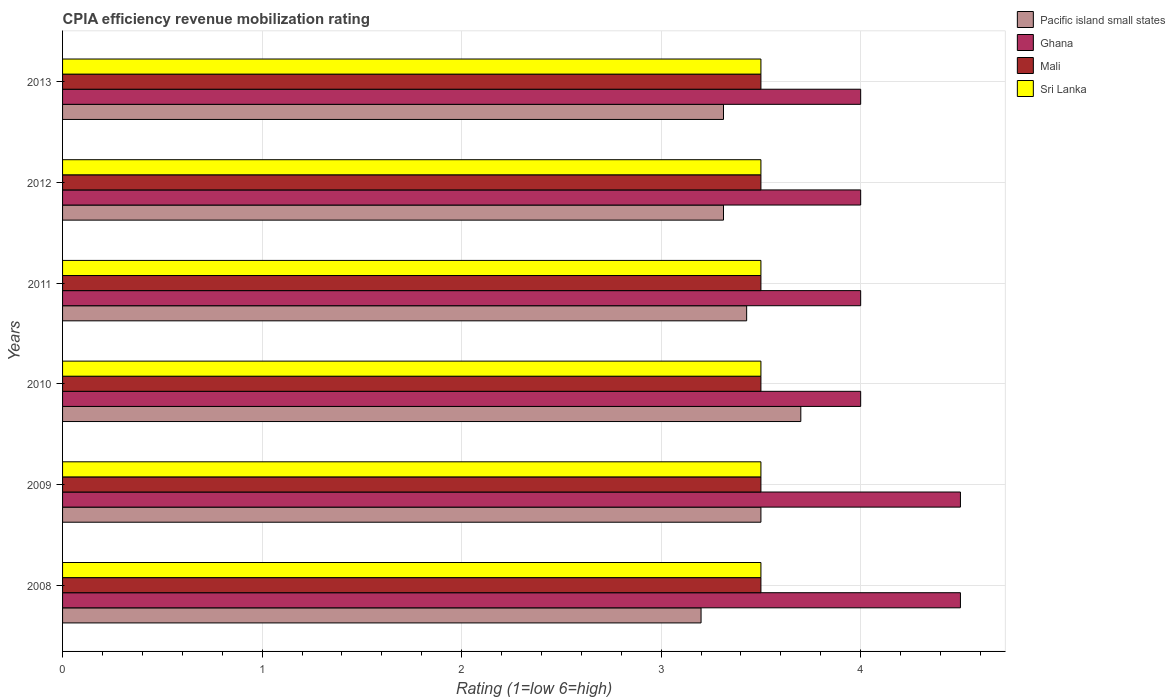How many different coloured bars are there?
Your answer should be compact. 4. How many groups of bars are there?
Your answer should be very brief. 6. Are the number of bars per tick equal to the number of legend labels?
Keep it short and to the point. Yes. Are the number of bars on each tick of the Y-axis equal?
Ensure brevity in your answer.  Yes. What is the label of the 5th group of bars from the top?
Offer a very short reply. 2009. Across all years, what is the maximum CPIA rating in Sri Lanka?
Keep it short and to the point. 3.5. In which year was the CPIA rating in Ghana maximum?
Ensure brevity in your answer.  2008. What is the total CPIA rating in Mali in the graph?
Ensure brevity in your answer.  21. What is the difference between the CPIA rating in Pacific island small states in 2012 and that in 2013?
Offer a terse response. 0. What is the difference between the CPIA rating in Mali in 2009 and the CPIA rating in Pacific island small states in 2011?
Provide a succinct answer. 0.07. What is the average CPIA rating in Ghana per year?
Ensure brevity in your answer.  4.17. In the year 2012, what is the difference between the CPIA rating in Mali and CPIA rating in Pacific island small states?
Your answer should be very brief. 0.19. Is the CPIA rating in Sri Lanka in 2009 less than that in 2013?
Ensure brevity in your answer.  No. What is the difference between the highest and the second highest CPIA rating in Sri Lanka?
Keep it short and to the point. 0. What is the difference between the highest and the lowest CPIA rating in Ghana?
Provide a short and direct response. 0.5. Is the sum of the CPIA rating in Mali in 2010 and 2012 greater than the maximum CPIA rating in Sri Lanka across all years?
Ensure brevity in your answer.  Yes. What does the 2nd bar from the top in 2009 represents?
Make the answer very short. Mali. What does the 3rd bar from the bottom in 2012 represents?
Make the answer very short. Mali. How many bars are there?
Offer a terse response. 24. Are all the bars in the graph horizontal?
Make the answer very short. Yes. Does the graph contain grids?
Your response must be concise. Yes. How many legend labels are there?
Make the answer very short. 4. How are the legend labels stacked?
Your answer should be very brief. Vertical. What is the title of the graph?
Provide a succinct answer. CPIA efficiency revenue mobilization rating. What is the label or title of the X-axis?
Offer a terse response. Rating (1=low 6=high). What is the Rating (1=low 6=high) of Mali in 2008?
Ensure brevity in your answer.  3.5. What is the Rating (1=low 6=high) in Sri Lanka in 2008?
Offer a very short reply. 3.5. What is the Rating (1=low 6=high) in Pacific island small states in 2009?
Provide a short and direct response. 3.5. What is the Rating (1=low 6=high) in Mali in 2009?
Offer a terse response. 3.5. What is the Rating (1=low 6=high) of Sri Lanka in 2010?
Offer a very short reply. 3.5. What is the Rating (1=low 6=high) in Pacific island small states in 2011?
Make the answer very short. 3.43. What is the Rating (1=low 6=high) of Ghana in 2011?
Keep it short and to the point. 4. What is the Rating (1=low 6=high) of Sri Lanka in 2011?
Keep it short and to the point. 3.5. What is the Rating (1=low 6=high) of Pacific island small states in 2012?
Ensure brevity in your answer.  3.31. What is the Rating (1=low 6=high) in Ghana in 2012?
Ensure brevity in your answer.  4. What is the Rating (1=low 6=high) in Mali in 2012?
Keep it short and to the point. 3.5. What is the Rating (1=low 6=high) in Pacific island small states in 2013?
Your response must be concise. 3.31. What is the Rating (1=low 6=high) of Ghana in 2013?
Your response must be concise. 4. What is the Rating (1=low 6=high) of Sri Lanka in 2013?
Give a very brief answer. 3.5. Across all years, what is the maximum Rating (1=low 6=high) of Sri Lanka?
Your answer should be very brief. 3.5. Across all years, what is the minimum Rating (1=low 6=high) in Pacific island small states?
Provide a succinct answer. 3.2. Across all years, what is the minimum Rating (1=low 6=high) in Ghana?
Your answer should be very brief. 4. Across all years, what is the minimum Rating (1=low 6=high) in Mali?
Your answer should be very brief. 3.5. Across all years, what is the minimum Rating (1=low 6=high) in Sri Lanka?
Offer a very short reply. 3.5. What is the total Rating (1=low 6=high) in Pacific island small states in the graph?
Make the answer very short. 20.45. What is the total Rating (1=low 6=high) of Mali in the graph?
Offer a terse response. 21. What is the total Rating (1=low 6=high) of Sri Lanka in the graph?
Your answer should be compact. 21. What is the difference between the Rating (1=low 6=high) of Pacific island small states in 2008 and that in 2009?
Your answer should be compact. -0.3. What is the difference between the Rating (1=low 6=high) in Ghana in 2008 and that in 2009?
Keep it short and to the point. 0. What is the difference between the Rating (1=low 6=high) of Mali in 2008 and that in 2009?
Make the answer very short. 0. What is the difference between the Rating (1=low 6=high) in Sri Lanka in 2008 and that in 2009?
Provide a succinct answer. 0. What is the difference between the Rating (1=low 6=high) of Mali in 2008 and that in 2010?
Provide a succinct answer. 0. What is the difference between the Rating (1=low 6=high) in Sri Lanka in 2008 and that in 2010?
Give a very brief answer. 0. What is the difference between the Rating (1=low 6=high) of Pacific island small states in 2008 and that in 2011?
Offer a very short reply. -0.23. What is the difference between the Rating (1=low 6=high) in Ghana in 2008 and that in 2011?
Give a very brief answer. 0.5. What is the difference between the Rating (1=low 6=high) of Mali in 2008 and that in 2011?
Your answer should be very brief. 0. What is the difference between the Rating (1=low 6=high) in Pacific island small states in 2008 and that in 2012?
Offer a terse response. -0.11. What is the difference between the Rating (1=low 6=high) in Sri Lanka in 2008 and that in 2012?
Your response must be concise. 0. What is the difference between the Rating (1=low 6=high) of Pacific island small states in 2008 and that in 2013?
Your answer should be very brief. -0.11. What is the difference between the Rating (1=low 6=high) in Ghana in 2008 and that in 2013?
Provide a succinct answer. 0.5. What is the difference between the Rating (1=low 6=high) in Mali in 2008 and that in 2013?
Provide a succinct answer. 0. What is the difference between the Rating (1=low 6=high) in Sri Lanka in 2008 and that in 2013?
Your answer should be very brief. 0. What is the difference between the Rating (1=low 6=high) of Pacific island small states in 2009 and that in 2010?
Provide a short and direct response. -0.2. What is the difference between the Rating (1=low 6=high) in Pacific island small states in 2009 and that in 2011?
Keep it short and to the point. 0.07. What is the difference between the Rating (1=low 6=high) in Mali in 2009 and that in 2011?
Your answer should be compact. 0. What is the difference between the Rating (1=low 6=high) in Sri Lanka in 2009 and that in 2011?
Provide a succinct answer. 0. What is the difference between the Rating (1=low 6=high) in Pacific island small states in 2009 and that in 2012?
Offer a terse response. 0.19. What is the difference between the Rating (1=low 6=high) of Sri Lanka in 2009 and that in 2012?
Your answer should be very brief. 0. What is the difference between the Rating (1=low 6=high) in Pacific island small states in 2009 and that in 2013?
Ensure brevity in your answer.  0.19. What is the difference between the Rating (1=low 6=high) of Ghana in 2009 and that in 2013?
Ensure brevity in your answer.  0.5. What is the difference between the Rating (1=low 6=high) of Mali in 2009 and that in 2013?
Your answer should be compact. 0. What is the difference between the Rating (1=low 6=high) in Sri Lanka in 2009 and that in 2013?
Your answer should be very brief. 0. What is the difference between the Rating (1=low 6=high) in Pacific island small states in 2010 and that in 2011?
Provide a short and direct response. 0.27. What is the difference between the Rating (1=low 6=high) in Ghana in 2010 and that in 2011?
Your response must be concise. 0. What is the difference between the Rating (1=low 6=high) in Sri Lanka in 2010 and that in 2011?
Your answer should be compact. 0. What is the difference between the Rating (1=low 6=high) in Pacific island small states in 2010 and that in 2012?
Your answer should be compact. 0.39. What is the difference between the Rating (1=low 6=high) in Mali in 2010 and that in 2012?
Offer a very short reply. 0. What is the difference between the Rating (1=low 6=high) in Pacific island small states in 2010 and that in 2013?
Make the answer very short. 0.39. What is the difference between the Rating (1=low 6=high) in Pacific island small states in 2011 and that in 2012?
Keep it short and to the point. 0.12. What is the difference between the Rating (1=low 6=high) of Sri Lanka in 2011 and that in 2012?
Provide a succinct answer. 0. What is the difference between the Rating (1=low 6=high) in Pacific island small states in 2011 and that in 2013?
Provide a succinct answer. 0.12. What is the difference between the Rating (1=low 6=high) of Mali in 2011 and that in 2013?
Your answer should be very brief. 0. What is the difference between the Rating (1=low 6=high) in Sri Lanka in 2011 and that in 2013?
Make the answer very short. 0. What is the difference between the Rating (1=low 6=high) of Pacific island small states in 2012 and that in 2013?
Give a very brief answer. 0. What is the difference between the Rating (1=low 6=high) in Mali in 2012 and that in 2013?
Provide a succinct answer. 0. What is the difference between the Rating (1=low 6=high) in Sri Lanka in 2012 and that in 2013?
Make the answer very short. 0. What is the difference between the Rating (1=low 6=high) of Pacific island small states in 2008 and the Rating (1=low 6=high) of Ghana in 2009?
Your answer should be very brief. -1.3. What is the difference between the Rating (1=low 6=high) in Mali in 2008 and the Rating (1=low 6=high) in Sri Lanka in 2009?
Offer a very short reply. 0. What is the difference between the Rating (1=low 6=high) of Pacific island small states in 2008 and the Rating (1=low 6=high) of Ghana in 2010?
Ensure brevity in your answer.  -0.8. What is the difference between the Rating (1=low 6=high) of Pacific island small states in 2008 and the Rating (1=low 6=high) of Mali in 2010?
Your answer should be compact. -0.3. What is the difference between the Rating (1=low 6=high) in Pacific island small states in 2008 and the Rating (1=low 6=high) in Sri Lanka in 2010?
Make the answer very short. -0.3. What is the difference between the Rating (1=low 6=high) of Ghana in 2008 and the Rating (1=low 6=high) of Sri Lanka in 2010?
Provide a short and direct response. 1. What is the difference between the Rating (1=low 6=high) of Mali in 2008 and the Rating (1=low 6=high) of Sri Lanka in 2010?
Offer a terse response. 0. What is the difference between the Rating (1=low 6=high) of Pacific island small states in 2008 and the Rating (1=low 6=high) of Sri Lanka in 2011?
Your answer should be compact. -0.3. What is the difference between the Rating (1=low 6=high) of Ghana in 2008 and the Rating (1=low 6=high) of Mali in 2011?
Provide a succinct answer. 1. What is the difference between the Rating (1=low 6=high) of Mali in 2008 and the Rating (1=low 6=high) of Sri Lanka in 2011?
Your answer should be compact. 0. What is the difference between the Rating (1=low 6=high) of Pacific island small states in 2008 and the Rating (1=low 6=high) of Mali in 2012?
Give a very brief answer. -0.3. What is the difference between the Rating (1=low 6=high) in Ghana in 2008 and the Rating (1=low 6=high) in Sri Lanka in 2012?
Your answer should be very brief. 1. What is the difference between the Rating (1=low 6=high) in Pacific island small states in 2008 and the Rating (1=low 6=high) in Mali in 2013?
Give a very brief answer. -0.3. What is the difference between the Rating (1=low 6=high) in Pacific island small states in 2008 and the Rating (1=low 6=high) in Sri Lanka in 2013?
Give a very brief answer. -0.3. What is the difference between the Rating (1=low 6=high) in Mali in 2008 and the Rating (1=low 6=high) in Sri Lanka in 2013?
Your response must be concise. 0. What is the difference between the Rating (1=low 6=high) of Pacific island small states in 2009 and the Rating (1=low 6=high) of Ghana in 2010?
Make the answer very short. -0.5. What is the difference between the Rating (1=low 6=high) of Pacific island small states in 2009 and the Rating (1=low 6=high) of Sri Lanka in 2010?
Your response must be concise. 0. What is the difference between the Rating (1=low 6=high) in Ghana in 2009 and the Rating (1=low 6=high) in Sri Lanka in 2010?
Offer a terse response. 1. What is the difference between the Rating (1=low 6=high) in Mali in 2009 and the Rating (1=low 6=high) in Sri Lanka in 2010?
Offer a very short reply. 0. What is the difference between the Rating (1=low 6=high) in Pacific island small states in 2009 and the Rating (1=low 6=high) in Ghana in 2011?
Make the answer very short. -0.5. What is the difference between the Rating (1=low 6=high) of Pacific island small states in 2009 and the Rating (1=low 6=high) of Mali in 2011?
Provide a short and direct response. 0. What is the difference between the Rating (1=low 6=high) of Pacific island small states in 2009 and the Rating (1=low 6=high) of Sri Lanka in 2011?
Keep it short and to the point. 0. What is the difference between the Rating (1=low 6=high) in Ghana in 2009 and the Rating (1=low 6=high) in Sri Lanka in 2011?
Your answer should be compact. 1. What is the difference between the Rating (1=low 6=high) in Pacific island small states in 2009 and the Rating (1=low 6=high) in Sri Lanka in 2012?
Make the answer very short. 0. What is the difference between the Rating (1=low 6=high) in Ghana in 2009 and the Rating (1=low 6=high) in Sri Lanka in 2012?
Your response must be concise. 1. What is the difference between the Rating (1=low 6=high) in Mali in 2009 and the Rating (1=low 6=high) in Sri Lanka in 2012?
Your response must be concise. 0. What is the difference between the Rating (1=low 6=high) in Pacific island small states in 2010 and the Rating (1=low 6=high) in Ghana in 2011?
Give a very brief answer. -0.3. What is the difference between the Rating (1=low 6=high) in Pacific island small states in 2010 and the Rating (1=low 6=high) in Mali in 2011?
Offer a very short reply. 0.2. What is the difference between the Rating (1=low 6=high) in Pacific island small states in 2010 and the Rating (1=low 6=high) in Sri Lanka in 2011?
Provide a succinct answer. 0.2. What is the difference between the Rating (1=low 6=high) of Ghana in 2010 and the Rating (1=low 6=high) of Sri Lanka in 2011?
Your answer should be compact. 0.5. What is the difference between the Rating (1=low 6=high) of Pacific island small states in 2010 and the Rating (1=low 6=high) of Mali in 2012?
Make the answer very short. 0.2. What is the difference between the Rating (1=low 6=high) of Pacific island small states in 2010 and the Rating (1=low 6=high) of Sri Lanka in 2012?
Ensure brevity in your answer.  0.2. What is the difference between the Rating (1=low 6=high) of Ghana in 2010 and the Rating (1=low 6=high) of Sri Lanka in 2012?
Offer a very short reply. 0.5. What is the difference between the Rating (1=low 6=high) of Pacific island small states in 2010 and the Rating (1=low 6=high) of Ghana in 2013?
Your answer should be compact. -0.3. What is the difference between the Rating (1=low 6=high) in Pacific island small states in 2010 and the Rating (1=low 6=high) in Mali in 2013?
Your answer should be compact. 0.2. What is the difference between the Rating (1=low 6=high) of Pacific island small states in 2010 and the Rating (1=low 6=high) of Sri Lanka in 2013?
Ensure brevity in your answer.  0.2. What is the difference between the Rating (1=low 6=high) of Ghana in 2010 and the Rating (1=low 6=high) of Sri Lanka in 2013?
Your answer should be very brief. 0.5. What is the difference between the Rating (1=low 6=high) in Mali in 2010 and the Rating (1=low 6=high) in Sri Lanka in 2013?
Offer a terse response. 0. What is the difference between the Rating (1=low 6=high) in Pacific island small states in 2011 and the Rating (1=low 6=high) in Ghana in 2012?
Provide a succinct answer. -0.57. What is the difference between the Rating (1=low 6=high) in Pacific island small states in 2011 and the Rating (1=low 6=high) in Mali in 2012?
Your response must be concise. -0.07. What is the difference between the Rating (1=low 6=high) of Pacific island small states in 2011 and the Rating (1=low 6=high) of Sri Lanka in 2012?
Your answer should be compact. -0.07. What is the difference between the Rating (1=low 6=high) of Ghana in 2011 and the Rating (1=low 6=high) of Sri Lanka in 2012?
Your answer should be very brief. 0.5. What is the difference between the Rating (1=low 6=high) of Pacific island small states in 2011 and the Rating (1=low 6=high) of Ghana in 2013?
Provide a succinct answer. -0.57. What is the difference between the Rating (1=low 6=high) of Pacific island small states in 2011 and the Rating (1=low 6=high) of Mali in 2013?
Your answer should be very brief. -0.07. What is the difference between the Rating (1=low 6=high) of Pacific island small states in 2011 and the Rating (1=low 6=high) of Sri Lanka in 2013?
Provide a succinct answer. -0.07. What is the difference between the Rating (1=low 6=high) in Pacific island small states in 2012 and the Rating (1=low 6=high) in Ghana in 2013?
Your answer should be compact. -0.69. What is the difference between the Rating (1=low 6=high) in Pacific island small states in 2012 and the Rating (1=low 6=high) in Mali in 2013?
Provide a short and direct response. -0.19. What is the difference between the Rating (1=low 6=high) of Pacific island small states in 2012 and the Rating (1=low 6=high) of Sri Lanka in 2013?
Make the answer very short. -0.19. What is the average Rating (1=low 6=high) of Pacific island small states per year?
Provide a short and direct response. 3.41. What is the average Rating (1=low 6=high) in Ghana per year?
Ensure brevity in your answer.  4.17. In the year 2008, what is the difference between the Rating (1=low 6=high) in Pacific island small states and Rating (1=low 6=high) in Mali?
Ensure brevity in your answer.  -0.3. In the year 2008, what is the difference between the Rating (1=low 6=high) of Ghana and Rating (1=low 6=high) of Mali?
Provide a short and direct response. 1. In the year 2008, what is the difference between the Rating (1=low 6=high) in Mali and Rating (1=low 6=high) in Sri Lanka?
Keep it short and to the point. 0. In the year 2009, what is the difference between the Rating (1=low 6=high) in Pacific island small states and Rating (1=low 6=high) in Mali?
Offer a terse response. 0. In the year 2009, what is the difference between the Rating (1=low 6=high) in Pacific island small states and Rating (1=low 6=high) in Sri Lanka?
Offer a terse response. 0. In the year 2009, what is the difference between the Rating (1=low 6=high) in Ghana and Rating (1=low 6=high) in Sri Lanka?
Make the answer very short. 1. In the year 2009, what is the difference between the Rating (1=low 6=high) of Mali and Rating (1=low 6=high) of Sri Lanka?
Your response must be concise. 0. In the year 2010, what is the difference between the Rating (1=low 6=high) of Pacific island small states and Rating (1=low 6=high) of Ghana?
Keep it short and to the point. -0.3. In the year 2010, what is the difference between the Rating (1=low 6=high) in Pacific island small states and Rating (1=low 6=high) in Mali?
Offer a very short reply. 0.2. In the year 2010, what is the difference between the Rating (1=low 6=high) in Ghana and Rating (1=low 6=high) in Sri Lanka?
Your answer should be very brief. 0.5. In the year 2010, what is the difference between the Rating (1=low 6=high) of Mali and Rating (1=low 6=high) of Sri Lanka?
Ensure brevity in your answer.  0. In the year 2011, what is the difference between the Rating (1=low 6=high) in Pacific island small states and Rating (1=low 6=high) in Ghana?
Your answer should be very brief. -0.57. In the year 2011, what is the difference between the Rating (1=low 6=high) in Pacific island small states and Rating (1=low 6=high) in Mali?
Your response must be concise. -0.07. In the year 2011, what is the difference between the Rating (1=low 6=high) of Pacific island small states and Rating (1=low 6=high) of Sri Lanka?
Offer a terse response. -0.07. In the year 2011, what is the difference between the Rating (1=low 6=high) in Mali and Rating (1=low 6=high) in Sri Lanka?
Provide a succinct answer. 0. In the year 2012, what is the difference between the Rating (1=low 6=high) of Pacific island small states and Rating (1=low 6=high) of Ghana?
Provide a short and direct response. -0.69. In the year 2012, what is the difference between the Rating (1=low 6=high) in Pacific island small states and Rating (1=low 6=high) in Mali?
Offer a very short reply. -0.19. In the year 2012, what is the difference between the Rating (1=low 6=high) in Pacific island small states and Rating (1=low 6=high) in Sri Lanka?
Your answer should be very brief. -0.19. In the year 2012, what is the difference between the Rating (1=low 6=high) of Ghana and Rating (1=low 6=high) of Mali?
Provide a short and direct response. 0.5. In the year 2012, what is the difference between the Rating (1=low 6=high) of Ghana and Rating (1=low 6=high) of Sri Lanka?
Offer a terse response. 0.5. In the year 2013, what is the difference between the Rating (1=low 6=high) of Pacific island small states and Rating (1=low 6=high) of Ghana?
Make the answer very short. -0.69. In the year 2013, what is the difference between the Rating (1=low 6=high) in Pacific island small states and Rating (1=low 6=high) in Mali?
Keep it short and to the point. -0.19. In the year 2013, what is the difference between the Rating (1=low 6=high) in Pacific island small states and Rating (1=low 6=high) in Sri Lanka?
Keep it short and to the point. -0.19. In the year 2013, what is the difference between the Rating (1=low 6=high) of Ghana and Rating (1=low 6=high) of Mali?
Offer a terse response. 0.5. What is the ratio of the Rating (1=low 6=high) of Pacific island small states in 2008 to that in 2009?
Offer a very short reply. 0.91. What is the ratio of the Rating (1=low 6=high) of Mali in 2008 to that in 2009?
Offer a very short reply. 1. What is the ratio of the Rating (1=low 6=high) of Sri Lanka in 2008 to that in 2009?
Offer a terse response. 1. What is the ratio of the Rating (1=low 6=high) of Pacific island small states in 2008 to that in 2010?
Make the answer very short. 0.86. What is the ratio of the Rating (1=low 6=high) of Ghana in 2008 to that in 2010?
Give a very brief answer. 1.12. What is the ratio of the Rating (1=low 6=high) of Sri Lanka in 2008 to that in 2010?
Make the answer very short. 1. What is the ratio of the Rating (1=low 6=high) of Ghana in 2008 to that in 2011?
Your response must be concise. 1.12. What is the ratio of the Rating (1=low 6=high) of Mali in 2008 to that in 2011?
Provide a short and direct response. 1. What is the ratio of the Rating (1=low 6=high) of Sri Lanka in 2008 to that in 2011?
Ensure brevity in your answer.  1. What is the ratio of the Rating (1=low 6=high) of Pacific island small states in 2008 to that in 2012?
Offer a terse response. 0.97. What is the ratio of the Rating (1=low 6=high) of Mali in 2008 to that in 2012?
Your response must be concise. 1. What is the ratio of the Rating (1=low 6=high) of Sri Lanka in 2008 to that in 2012?
Offer a very short reply. 1. What is the ratio of the Rating (1=low 6=high) of Mali in 2008 to that in 2013?
Your answer should be compact. 1. What is the ratio of the Rating (1=low 6=high) in Pacific island small states in 2009 to that in 2010?
Give a very brief answer. 0.95. What is the ratio of the Rating (1=low 6=high) of Mali in 2009 to that in 2010?
Give a very brief answer. 1. What is the ratio of the Rating (1=low 6=high) in Sri Lanka in 2009 to that in 2010?
Keep it short and to the point. 1. What is the ratio of the Rating (1=low 6=high) in Pacific island small states in 2009 to that in 2011?
Provide a succinct answer. 1.02. What is the ratio of the Rating (1=low 6=high) in Pacific island small states in 2009 to that in 2012?
Your answer should be compact. 1.06. What is the ratio of the Rating (1=low 6=high) of Ghana in 2009 to that in 2012?
Provide a succinct answer. 1.12. What is the ratio of the Rating (1=low 6=high) in Sri Lanka in 2009 to that in 2012?
Offer a terse response. 1. What is the ratio of the Rating (1=low 6=high) in Pacific island small states in 2009 to that in 2013?
Keep it short and to the point. 1.06. What is the ratio of the Rating (1=low 6=high) of Mali in 2009 to that in 2013?
Your response must be concise. 1. What is the ratio of the Rating (1=low 6=high) in Sri Lanka in 2009 to that in 2013?
Your response must be concise. 1. What is the ratio of the Rating (1=low 6=high) in Pacific island small states in 2010 to that in 2011?
Offer a very short reply. 1.08. What is the ratio of the Rating (1=low 6=high) of Ghana in 2010 to that in 2011?
Your response must be concise. 1. What is the ratio of the Rating (1=low 6=high) of Mali in 2010 to that in 2011?
Your answer should be compact. 1. What is the ratio of the Rating (1=low 6=high) in Pacific island small states in 2010 to that in 2012?
Provide a succinct answer. 1.12. What is the ratio of the Rating (1=low 6=high) in Ghana in 2010 to that in 2012?
Offer a terse response. 1. What is the ratio of the Rating (1=low 6=high) in Mali in 2010 to that in 2012?
Your answer should be compact. 1. What is the ratio of the Rating (1=low 6=high) of Sri Lanka in 2010 to that in 2012?
Give a very brief answer. 1. What is the ratio of the Rating (1=low 6=high) in Pacific island small states in 2010 to that in 2013?
Offer a very short reply. 1.12. What is the ratio of the Rating (1=low 6=high) of Ghana in 2010 to that in 2013?
Give a very brief answer. 1. What is the ratio of the Rating (1=low 6=high) in Pacific island small states in 2011 to that in 2012?
Provide a succinct answer. 1.03. What is the ratio of the Rating (1=low 6=high) in Sri Lanka in 2011 to that in 2012?
Provide a short and direct response. 1. What is the ratio of the Rating (1=low 6=high) in Pacific island small states in 2011 to that in 2013?
Make the answer very short. 1.03. What is the ratio of the Rating (1=low 6=high) in Ghana in 2012 to that in 2013?
Your answer should be very brief. 1. What is the ratio of the Rating (1=low 6=high) in Sri Lanka in 2012 to that in 2013?
Keep it short and to the point. 1. What is the difference between the highest and the second highest Rating (1=low 6=high) in Sri Lanka?
Provide a succinct answer. 0. What is the difference between the highest and the lowest Rating (1=low 6=high) of Pacific island small states?
Your answer should be compact. 0.5. What is the difference between the highest and the lowest Rating (1=low 6=high) in Mali?
Your answer should be very brief. 0. What is the difference between the highest and the lowest Rating (1=low 6=high) in Sri Lanka?
Keep it short and to the point. 0. 